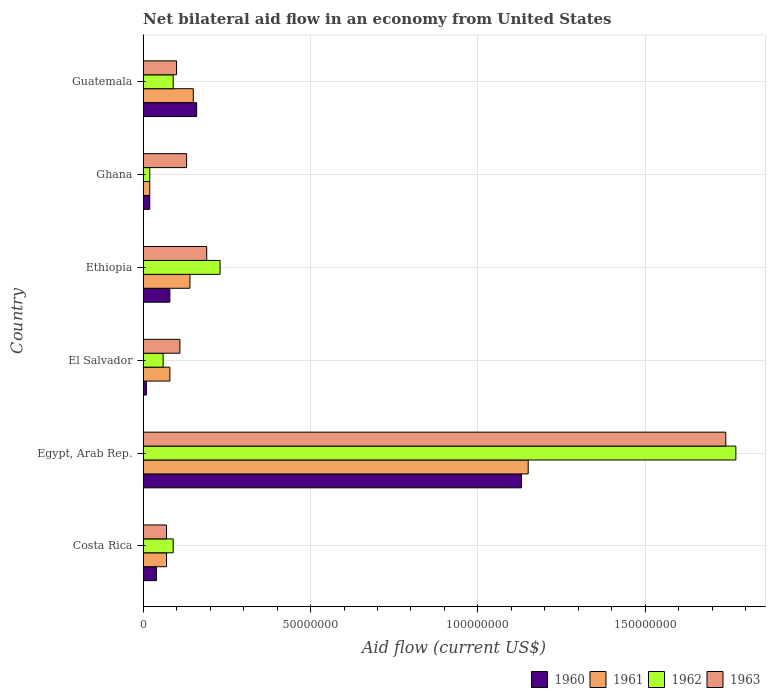How many groups of bars are there?
Offer a terse response. 6. Are the number of bars per tick equal to the number of legend labels?
Keep it short and to the point. Yes. How many bars are there on the 4th tick from the top?
Make the answer very short. 4. What is the label of the 1st group of bars from the top?
Your answer should be very brief. Guatemala. What is the net bilateral aid flow in 1960 in Costa Rica?
Your answer should be compact. 4.00e+06. Across all countries, what is the maximum net bilateral aid flow in 1960?
Keep it short and to the point. 1.13e+08. In which country was the net bilateral aid flow in 1962 maximum?
Give a very brief answer. Egypt, Arab Rep. In which country was the net bilateral aid flow in 1961 minimum?
Ensure brevity in your answer.  Ghana. What is the total net bilateral aid flow in 1961 in the graph?
Your answer should be very brief. 1.61e+08. What is the difference between the net bilateral aid flow in 1962 in Ghana and that in Guatemala?
Provide a short and direct response. -7.00e+06. What is the difference between the net bilateral aid flow in 1961 in Guatemala and the net bilateral aid flow in 1960 in Ethiopia?
Keep it short and to the point. 7.00e+06. What is the average net bilateral aid flow in 1961 per country?
Keep it short and to the point. 2.68e+07. What is the difference between the net bilateral aid flow in 1963 and net bilateral aid flow in 1962 in Ethiopia?
Provide a succinct answer. -4.00e+06. What is the ratio of the net bilateral aid flow in 1963 in Costa Rica to that in El Salvador?
Your response must be concise. 0.64. Is the difference between the net bilateral aid flow in 1963 in Egypt, Arab Rep. and Ghana greater than the difference between the net bilateral aid flow in 1962 in Egypt, Arab Rep. and Ghana?
Keep it short and to the point. No. What is the difference between the highest and the second highest net bilateral aid flow in 1961?
Your answer should be compact. 1.00e+08. What is the difference between the highest and the lowest net bilateral aid flow in 1963?
Provide a short and direct response. 1.67e+08. Is the sum of the net bilateral aid flow in 1961 in Ethiopia and Ghana greater than the maximum net bilateral aid flow in 1963 across all countries?
Provide a short and direct response. No. Is it the case that in every country, the sum of the net bilateral aid flow in 1960 and net bilateral aid flow in 1961 is greater than the sum of net bilateral aid flow in 1963 and net bilateral aid flow in 1962?
Your response must be concise. No. Is it the case that in every country, the sum of the net bilateral aid flow in 1963 and net bilateral aid flow in 1960 is greater than the net bilateral aid flow in 1961?
Provide a short and direct response. Yes. How many bars are there?
Provide a succinct answer. 24. How many countries are there in the graph?
Your response must be concise. 6. Are the values on the major ticks of X-axis written in scientific E-notation?
Offer a very short reply. No. Where does the legend appear in the graph?
Provide a short and direct response. Bottom right. How many legend labels are there?
Provide a succinct answer. 4. How are the legend labels stacked?
Offer a terse response. Horizontal. What is the title of the graph?
Provide a succinct answer. Net bilateral aid flow in an economy from United States. Does "2012" appear as one of the legend labels in the graph?
Provide a short and direct response. No. What is the Aid flow (current US$) in 1960 in Costa Rica?
Offer a terse response. 4.00e+06. What is the Aid flow (current US$) of 1962 in Costa Rica?
Keep it short and to the point. 9.00e+06. What is the Aid flow (current US$) of 1960 in Egypt, Arab Rep.?
Your response must be concise. 1.13e+08. What is the Aid flow (current US$) in 1961 in Egypt, Arab Rep.?
Offer a terse response. 1.15e+08. What is the Aid flow (current US$) in 1962 in Egypt, Arab Rep.?
Your answer should be compact. 1.77e+08. What is the Aid flow (current US$) of 1963 in Egypt, Arab Rep.?
Your response must be concise. 1.74e+08. What is the Aid flow (current US$) of 1960 in El Salvador?
Make the answer very short. 1.00e+06. What is the Aid flow (current US$) in 1961 in El Salvador?
Your response must be concise. 8.00e+06. What is the Aid flow (current US$) of 1963 in El Salvador?
Make the answer very short. 1.10e+07. What is the Aid flow (current US$) of 1961 in Ethiopia?
Ensure brevity in your answer.  1.40e+07. What is the Aid flow (current US$) of 1962 in Ethiopia?
Offer a very short reply. 2.30e+07. What is the Aid flow (current US$) of 1963 in Ethiopia?
Offer a terse response. 1.90e+07. What is the Aid flow (current US$) of 1963 in Ghana?
Make the answer very short. 1.30e+07. What is the Aid flow (current US$) of 1960 in Guatemala?
Offer a very short reply. 1.60e+07. What is the Aid flow (current US$) of 1961 in Guatemala?
Provide a succinct answer. 1.50e+07. What is the Aid flow (current US$) of 1962 in Guatemala?
Offer a terse response. 9.00e+06. What is the Aid flow (current US$) of 1963 in Guatemala?
Offer a terse response. 1.00e+07. Across all countries, what is the maximum Aid flow (current US$) of 1960?
Keep it short and to the point. 1.13e+08. Across all countries, what is the maximum Aid flow (current US$) of 1961?
Provide a succinct answer. 1.15e+08. Across all countries, what is the maximum Aid flow (current US$) of 1962?
Give a very brief answer. 1.77e+08. Across all countries, what is the maximum Aid flow (current US$) of 1963?
Provide a succinct answer. 1.74e+08. Across all countries, what is the minimum Aid flow (current US$) of 1960?
Your answer should be very brief. 1.00e+06. Across all countries, what is the minimum Aid flow (current US$) of 1962?
Provide a succinct answer. 2.00e+06. What is the total Aid flow (current US$) of 1960 in the graph?
Ensure brevity in your answer.  1.44e+08. What is the total Aid flow (current US$) in 1961 in the graph?
Your response must be concise. 1.61e+08. What is the total Aid flow (current US$) of 1962 in the graph?
Offer a very short reply. 2.26e+08. What is the total Aid flow (current US$) of 1963 in the graph?
Your answer should be compact. 2.34e+08. What is the difference between the Aid flow (current US$) of 1960 in Costa Rica and that in Egypt, Arab Rep.?
Provide a short and direct response. -1.09e+08. What is the difference between the Aid flow (current US$) of 1961 in Costa Rica and that in Egypt, Arab Rep.?
Your response must be concise. -1.08e+08. What is the difference between the Aid flow (current US$) of 1962 in Costa Rica and that in Egypt, Arab Rep.?
Provide a short and direct response. -1.68e+08. What is the difference between the Aid flow (current US$) in 1963 in Costa Rica and that in Egypt, Arab Rep.?
Provide a succinct answer. -1.67e+08. What is the difference between the Aid flow (current US$) in 1960 in Costa Rica and that in El Salvador?
Your answer should be very brief. 3.00e+06. What is the difference between the Aid flow (current US$) in 1961 in Costa Rica and that in El Salvador?
Give a very brief answer. -1.00e+06. What is the difference between the Aid flow (current US$) in 1963 in Costa Rica and that in El Salvador?
Keep it short and to the point. -4.00e+06. What is the difference between the Aid flow (current US$) of 1960 in Costa Rica and that in Ethiopia?
Make the answer very short. -4.00e+06. What is the difference between the Aid flow (current US$) of 1961 in Costa Rica and that in Ethiopia?
Ensure brevity in your answer.  -7.00e+06. What is the difference between the Aid flow (current US$) in 1962 in Costa Rica and that in Ethiopia?
Ensure brevity in your answer.  -1.40e+07. What is the difference between the Aid flow (current US$) in 1963 in Costa Rica and that in Ethiopia?
Offer a very short reply. -1.20e+07. What is the difference between the Aid flow (current US$) of 1962 in Costa Rica and that in Ghana?
Your answer should be very brief. 7.00e+06. What is the difference between the Aid flow (current US$) in 1963 in Costa Rica and that in Ghana?
Offer a very short reply. -6.00e+06. What is the difference between the Aid flow (current US$) of 1960 in Costa Rica and that in Guatemala?
Offer a very short reply. -1.20e+07. What is the difference between the Aid flow (current US$) of 1961 in Costa Rica and that in Guatemala?
Keep it short and to the point. -8.00e+06. What is the difference between the Aid flow (current US$) of 1960 in Egypt, Arab Rep. and that in El Salvador?
Keep it short and to the point. 1.12e+08. What is the difference between the Aid flow (current US$) in 1961 in Egypt, Arab Rep. and that in El Salvador?
Offer a very short reply. 1.07e+08. What is the difference between the Aid flow (current US$) of 1962 in Egypt, Arab Rep. and that in El Salvador?
Provide a succinct answer. 1.71e+08. What is the difference between the Aid flow (current US$) of 1963 in Egypt, Arab Rep. and that in El Salvador?
Offer a terse response. 1.63e+08. What is the difference between the Aid flow (current US$) in 1960 in Egypt, Arab Rep. and that in Ethiopia?
Ensure brevity in your answer.  1.05e+08. What is the difference between the Aid flow (current US$) of 1961 in Egypt, Arab Rep. and that in Ethiopia?
Your answer should be very brief. 1.01e+08. What is the difference between the Aid flow (current US$) in 1962 in Egypt, Arab Rep. and that in Ethiopia?
Offer a terse response. 1.54e+08. What is the difference between the Aid flow (current US$) in 1963 in Egypt, Arab Rep. and that in Ethiopia?
Your answer should be very brief. 1.55e+08. What is the difference between the Aid flow (current US$) in 1960 in Egypt, Arab Rep. and that in Ghana?
Make the answer very short. 1.11e+08. What is the difference between the Aid flow (current US$) in 1961 in Egypt, Arab Rep. and that in Ghana?
Your answer should be very brief. 1.13e+08. What is the difference between the Aid flow (current US$) in 1962 in Egypt, Arab Rep. and that in Ghana?
Offer a terse response. 1.75e+08. What is the difference between the Aid flow (current US$) in 1963 in Egypt, Arab Rep. and that in Ghana?
Offer a terse response. 1.61e+08. What is the difference between the Aid flow (current US$) in 1960 in Egypt, Arab Rep. and that in Guatemala?
Your answer should be very brief. 9.70e+07. What is the difference between the Aid flow (current US$) in 1962 in Egypt, Arab Rep. and that in Guatemala?
Offer a terse response. 1.68e+08. What is the difference between the Aid flow (current US$) of 1963 in Egypt, Arab Rep. and that in Guatemala?
Your answer should be very brief. 1.64e+08. What is the difference between the Aid flow (current US$) of 1960 in El Salvador and that in Ethiopia?
Provide a short and direct response. -7.00e+06. What is the difference between the Aid flow (current US$) in 1961 in El Salvador and that in Ethiopia?
Keep it short and to the point. -6.00e+06. What is the difference between the Aid flow (current US$) in 1962 in El Salvador and that in Ethiopia?
Make the answer very short. -1.70e+07. What is the difference between the Aid flow (current US$) of 1963 in El Salvador and that in Ethiopia?
Provide a succinct answer. -8.00e+06. What is the difference between the Aid flow (current US$) in 1960 in El Salvador and that in Ghana?
Your answer should be compact. -1.00e+06. What is the difference between the Aid flow (current US$) in 1961 in El Salvador and that in Ghana?
Ensure brevity in your answer.  6.00e+06. What is the difference between the Aid flow (current US$) of 1963 in El Salvador and that in Ghana?
Your answer should be very brief. -2.00e+06. What is the difference between the Aid flow (current US$) of 1960 in El Salvador and that in Guatemala?
Give a very brief answer. -1.50e+07. What is the difference between the Aid flow (current US$) in 1961 in El Salvador and that in Guatemala?
Provide a short and direct response. -7.00e+06. What is the difference between the Aid flow (current US$) in 1962 in El Salvador and that in Guatemala?
Your answer should be compact. -3.00e+06. What is the difference between the Aid flow (current US$) in 1963 in El Salvador and that in Guatemala?
Your answer should be very brief. 1.00e+06. What is the difference between the Aid flow (current US$) of 1961 in Ethiopia and that in Ghana?
Your response must be concise. 1.20e+07. What is the difference between the Aid flow (current US$) of 1962 in Ethiopia and that in Ghana?
Provide a short and direct response. 2.10e+07. What is the difference between the Aid flow (current US$) in 1960 in Ethiopia and that in Guatemala?
Your answer should be compact. -8.00e+06. What is the difference between the Aid flow (current US$) of 1962 in Ethiopia and that in Guatemala?
Your answer should be very brief. 1.40e+07. What is the difference between the Aid flow (current US$) of 1963 in Ethiopia and that in Guatemala?
Give a very brief answer. 9.00e+06. What is the difference between the Aid flow (current US$) in 1960 in Ghana and that in Guatemala?
Offer a very short reply. -1.40e+07. What is the difference between the Aid flow (current US$) of 1961 in Ghana and that in Guatemala?
Your answer should be very brief. -1.30e+07. What is the difference between the Aid flow (current US$) of 1962 in Ghana and that in Guatemala?
Your answer should be very brief. -7.00e+06. What is the difference between the Aid flow (current US$) of 1963 in Ghana and that in Guatemala?
Your answer should be very brief. 3.00e+06. What is the difference between the Aid flow (current US$) of 1960 in Costa Rica and the Aid flow (current US$) of 1961 in Egypt, Arab Rep.?
Your response must be concise. -1.11e+08. What is the difference between the Aid flow (current US$) of 1960 in Costa Rica and the Aid flow (current US$) of 1962 in Egypt, Arab Rep.?
Provide a short and direct response. -1.73e+08. What is the difference between the Aid flow (current US$) of 1960 in Costa Rica and the Aid flow (current US$) of 1963 in Egypt, Arab Rep.?
Make the answer very short. -1.70e+08. What is the difference between the Aid flow (current US$) of 1961 in Costa Rica and the Aid flow (current US$) of 1962 in Egypt, Arab Rep.?
Keep it short and to the point. -1.70e+08. What is the difference between the Aid flow (current US$) of 1961 in Costa Rica and the Aid flow (current US$) of 1963 in Egypt, Arab Rep.?
Ensure brevity in your answer.  -1.67e+08. What is the difference between the Aid flow (current US$) in 1962 in Costa Rica and the Aid flow (current US$) in 1963 in Egypt, Arab Rep.?
Give a very brief answer. -1.65e+08. What is the difference between the Aid flow (current US$) in 1960 in Costa Rica and the Aid flow (current US$) in 1961 in El Salvador?
Provide a succinct answer. -4.00e+06. What is the difference between the Aid flow (current US$) in 1960 in Costa Rica and the Aid flow (current US$) in 1963 in El Salvador?
Give a very brief answer. -7.00e+06. What is the difference between the Aid flow (current US$) of 1962 in Costa Rica and the Aid flow (current US$) of 1963 in El Salvador?
Your answer should be compact. -2.00e+06. What is the difference between the Aid flow (current US$) in 1960 in Costa Rica and the Aid flow (current US$) in 1961 in Ethiopia?
Offer a terse response. -1.00e+07. What is the difference between the Aid flow (current US$) of 1960 in Costa Rica and the Aid flow (current US$) of 1962 in Ethiopia?
Keep it short and to the point. -1.90e+07. What is the difference between the Aid flow (current US$) of 1960 in Costa Rica and the Aid flow (current US$) of 1963 in Ethiopia?
Give a very brief answer. -1.50e+07. What is the difference between the Aid flow (current US$) in 1961 in Costa Rica and the Aid flow (current US$) in 1962 in Ethiopia?
Give a very brief answer. -1.60e+07. What is the difference between the Aid flow (current US$) in 1961 in Costa Rica and the Aid flow (current US$) in 1963 in Ethiopia?
Your answer should be very brief. -1.20e+07. What is the difference between the Aid flow (current US$) in 1962 in Costa Rica and the Aid flow (current US$) in 1963 in Ethiopia?
Ensure brevity in your answer.  -1.00e+07. What is the difference between the Aid flow (current US$) in 1960 in Costa Rica and the Aid flow (current US$) in 1961 in Ghana?
Provide a succinct answer. 2.00e+06. What is the difference between the Aid flow (current US$) in 1960 in Costa Rica and the Aid flow (current US$) in 1963 in Ghana?
Provide a short and direct response. -9.00e+06. What is the difference between the Aid flow (current US$) of 1961 in Costa Rica and the Aid flow (current US$) of 1962 in Ghana?
Your answer should be very brief. 5.00e+06. What is the difference between the Aid flow (current US$) of 1961 in Costa Rica and the Aid flow (current US$) of 1963 in Ghana?
Keep it short and to the point. -6.00e+06. What is the difference between the Aid flow (current US$) of 1960 in Costa Rica and the Aid flow (current US$) of 1961 in Guatemala?
Provide a short and direct response. -1.10e+07. What is the difference between the Aid flow (current US$) in 1960 in Costa Rica and the Aid flow (current US$) in 1962 in Guatemala?
Your answer should be very brief. -5.00e+06. What is the difference between the Aid flow (current US$) of 1960 in Costa Rica and the Aid flow (current US$) of 1963 in Guatemala?
Offer a very short reply. -6.00e+06. What is the difference between the Aid flow (current US$) in 1961 in Costa Rica and the Aid flow (current US$) in 1963 in Guatemala?
Keep it short and to the point. -3.00e+06. What is the difference between the Aid flow (current US$) in 1962 in Costa Rica and the Aid flow (current US$) in 1963 in Guatemala?
Make the answer very short. -1.00e+06. What is the difference between the Aid flow (current US$) of 1960 in Egypt, Arab Rep. and the Aid flow (current US$) of 1961 in El Salvador?
Keep it short and to the point. 1.05e+08. What is the difference between the Aid flow (current US$) of 1960 in Egypt, Arab Rep. and the Aid flow (current US$) of 1962 in El Salvador?
Provide a succinct answer. 1.07e+08. What is the difference between the Aid flow (current US$) of 1960 in Egypt, Arab Rep. and the Aid flow (current US$) of 1963 in El Salvador?
Make the answer very short. 1.02e+08. What is the difference between the Aid flow (current US$) in 1961 in Egypt, Arab Rep. and the Aid flow (current US$) in 1962 in El Salvador?
Keep it short and to the point. 1.09e+08. What is the difference between the Aid flow (current US$) of 1961 in Egypt, Arab Rep. and the Aid flow (current US$) of 1963 in El Salvador?
Your answer should be very brief. 1.04e+08. What is the difference between the Aid flow (current US$) of 1962 in Egypt, Arab Rep. and the Aid flow (current US$) of 1963 in El Salvador?
Offer a terse response. 1.66e+08. What is the difference between the Aid flow (current US$) of 1960 in Egypt, Arab Rep. and the Aid flow (current US$) of 1961 in Ethiopia?
Provide a succinct answer. 9.90e+07. What is the difference between the Aid flow (current US$) in 1960 in Egypt, Arab Rep. and the Aid flow (current US$) in 1962 in Ethiopia?
Your response must be concise. 9.00e+07. What is the difference between the Aid flow (current US$) in 1960 in Egypt, Arab Rep. and the Aid flow (current US$) in 1963 in Ethiopia?
Your response must be concise. 9.40e+07. What is the difference between the Aid flow (current US$) of 1961 in Egypt, Arab Rep. and the Aid flow (current US$) of 1962 in Ethiopia?
Offer a very short reply. 9.20e+07. What is the difference between the Aid flow (current US$) of 1961 in Egypt, Arab Rep. and the Aid flow (current US$) of 1963 in Ethiopia?
Provide a succinct answer. 9.60e+07. What is the difference between the Aid flow (current US$) of 1962 in Egypt, Arab Rep. and the Aid flow (current US$) of 1963 in Ethiopia?
Your answer should be compact. 1.58e+08. What is the difference between the Aid flow (current US$) in 1960 in Egypt, Arab Rep. and the Aid flow (current US$) in 1961 in Ghana?
Keep it short and to the point. 1.11e+08. What is the difference between the Aid flow (current US$) of 1960 in Egypt, Arab Rep. and the Aid flow (current US$) of 1962 in Ghana?
Give a very brief answer. 1.11e+08. What is the difference between the Aid flow (current US$) of 1960 in Egypt, Arab Rep. and the Aid flow (current US$) of 1963 in Ghana?
Provide a short and direct response. 1.00e+08. What is the difference between the Aid flow (current US$) in 1961 in Egypt, Arab Rep. and the Aid flow (current US$) in 1962 in Ghana?
Your answer should be compact. 1.13e+08. What is the difference between the Aid flow (current US$) of 1961 in Egypt, Arab Rep. and the Aid flow (current US$) of 1963 in Ghana?
Give a very brief answer. 1.02e+08. What is the difference between the Aid flow (current US$) of 1962 in Egypt, Arab Rep. and the Aid flow (current US$) of 1963 in Ghana?
Your answer should be very brief. 1.64e+08. What is the difference between the Aid flow (current US$) of 1960 in Egypt, Arab Rep. and the Aid flow (current US$) of 1961 in Guatemala?
Offer a very short reply. 9.80e+07. What is the difference between the Aid flow (current US$) in 1960 in Egypt, Arab Rep. and the Aid flow (current US$) in 1962 in Guatemala?
Provide a succinct answer. 1.04e+08. What is the difference between the Aid flow (current US$) in 1960 in Egypt, Arab Rep. and the Aid flow (current US$) in 1963 in Guatemala?
Your answer should be compact. 1.03e+08. What is the difference between the Aid flow (current US$) in 1961 in Egypt, Arab Rep. and the Aid flow (current US$) in 1962 in Guatemala?
Ensure brevity in your answer.  1.06e+08. What is the difference between the Aid flow (current US$) of 1961 in Egypt, Arab Rep. and the Aid flow (current US$) of 1963 in Guatemala?
Keep it short and to the point. 1.05e+08. What is the difference between the Aid flow (current US$) of 1962 in Egypt, Arab Rep. and the Aid flow (current US$) of 1963 in Guatemala?
Your answer should be very brief. 1.67e+08. What is the difference between the Aid flow (current US$) of 1960 in El Salvador and the Aid flow (current US$) of 1961 in Ethiopia?
Make the answer very short. -1.30e+07. What is the difference between the Aid flow (current US$) in 1960 in El Salvador and the Aid flow (current US$) in 1962 in Ethiopia?
Provide a short and direct response. -2.20e+07. What is the difference between the Aid flow (current US$) in 1960 in El Salvador and the Aid flow (current US$) in 1963 in Ethiopia?
Your response must be concise. -1.80e+07. What is the difference between the Aid flow (current US$) in 1961 in El Salvador and the Aid flow (current US$) in 1962 in Ethiopia?
Ensure brevity in your answer.  -1.50e+07. What is the difference between the Aid flow (current US$) in 1961 in El Salvador and the Aid flow (current US$) in 1963 in Ethiopia?
Ensure brevity in your answer.  -1.10e+07. What is the difference between the Aid flow (current US$) in 1962 in El Salvador and the Aid flow (current US$) in 1963 in Ethiopia?
Your answer should be very brief. -1.30e+07. What is the difference between the Aid flow (current US$) in 1960 in El Salvador and the Aid flow (current US$) in 1962 in Ghana?
Offer a very short reply. -1.00e+06. What is the difference between the Aid flow (current US$) in 1960 in El Salvador and the Aid flow (current US$) in 1963 in Ghana?
Your answer should be very brief. -1.20e+07. What is the difference between the Aid flow (current US$) of 1961 in El Salvador and the Aid flow (current US$) of 1962 in Ghana?
Provide a succinct answer. 6.00e+06. What is the difference between the Aid flow (current US$) in 1961 in El Salvador and the Aid flow (current US$) in 1963 in Ghana?
Keep it short and to the point. -5.00e+06. What is the difference between the Aid flow (current US$) in 1962 in El Salvador and the Aid flow (current US$) in 1963 in Ghana?
Make the answer very short. -7.00e+06. What is the difference between the Aid flow (current US$) of 1960 in El Salvador and the Aid flow (current US$) of 1961 in Guatemala?
Keep it short and to the point. -1.40e+07. What is the difference between the Aid flow (current US$) of 1960 in El Salvador and the Aid flow (current US$) of 1962 in Guatemala?
Your answer should be compact. -8.00e+06. What is the difference between the Aid flow (current US$) of 1960 in El Salvador and the Aid flow (current US$) of 1963 in Guatemala?
Keep it short and to the point. -9.00e+06. What is the difference between the Aid flow (current US$) in 1961 in El Salvador and the Aid flow (current US$) in 1962 in Guatemala?
Offer a very short reply. -1.00e+06. What is the difference between the Aid flow (current US$) in 1962 in El Salvador and the Aid flow (current US$) in 1963 in Guatemala?
Your answer should be compact. -4.00e+06. What is the difference between the Aid flow (current US$) of 1960 in Ethiopia and the Aid flow (current US$) of 1961 in Ghana?
Offer a terse response. 6.00e+06. What is the difference between the Aid flow (current US$) of 1960 in Ethiopia and the Aid flow (current US$) of 1963 in Ghana?
Offer a very short reply. -5.00e+06. What is the difference between the Aid flow (current US$) of 1961 in Ethiopia and the Aid flow (current US$) of 1962 in Ghana?
Keep it short and to the point. 1.20e+07. What is the difference between the Aid flow (current US$) in 1962 in Ethiopia and the Aid flow (current US$) in 1963 in Ghana?
Make the answer very short. 1.00e+07. What is the difference between the Aid flow (current US$) in 1960 in Ethiopia and the Aid flow (current US$) in 1961 in Guatemala?
Keep it short and to the point. -7.00e+06. What is the difference between the Aid flow (current US$) in 1960 in Ethiopia and the Aid flow (current US$) in 1962 in Guatemala?
Ensure brevity in your answer.  -1.00e+06. What is the difference between the Aid flow (current US$) of 1960 in Ethiopia and the Aid flow (current US$) of 1963 in Guatemala?
Keep it short and to the point. -2.00e+06. What is the difference between the Aid flow (current US$) of 1961 in Ethiopia and the Aid flow (current US$) of 1962 in Guatemala?
Keep it short and to the point. 5.00e+06. What is the difference between the Aid flow (current US$) in 1961 in Ethiopia and the Aid flow (current US$) in 1963 in Guatemala?
Ensure brevity in your answer.  4.00e+06. What is the difference between the Aid flow (current US$) of 1962 in Ethiopia and the Aid flow (current US$) of 1963 in Guatemala?
Give a very brief answer. 1.30e+07. What is the difference between the Aid flow (current US$) of 1960 in Ghana and the Aid flow (current US$) of 1961 in Guatemala?
Give a very brief answer. -1.30e+07. What is the difference between the Aid flow (current US$) of 1960 in Ghana and the Aid flow (current US$) of 1962 in Guatemala?
Your answer should be compact. -7.00e+06. What is the difference between the Aid flow (current US$) of 1960 in Ghana and the Aid flow (current US$) of 1963 in Guatemala?
Your response must be concise. -8.00e+06. What is the difference between the Aid flow (current US$) of 1961 in Ghana and the Aid flow (current US$) of 1962 in Guatemala?
Your response must be concise. -7.00e+06. What is the difference between the Aid flow (current US$) of 1961 in Ghana and the Aid flow (current US$) of 1963 in Guatemala?
Provide a short and direct response. -8.00e+06. What is the difference between the Aid flow (current US$) in 1962 in Ghana and the Aid flow (current US$) in 1963 in Guatemala?
Offer a terse response. -8.00e+06. What is the average Aid flow (current US$) in 1960 per country?
Offer a terse response. 2.40e+07. What is the average Aid flow (current US$) in 1961 per country?
Provide a succinct answer. 2.68e+07. What is the average Aid flow (current US$) of 1962 per country?
Make the answer very short. 3.77e+07. What is the average Aid flow (current US$) of 1963 per country?
Provide a succinct answer. 3.90e+07. What is the difference between the Aid flow (current US$) in 1960 and Aid flow (current US$) in 1962 in Costa Rica?
Give a very brief answer. -5.00e+06. What is the difference between the Aid flow (current US$) of 1960 and Aid flow (current US$) of 1963 in Costa Rica?
Your answer should be compact. -3.00e+06. What is the difference between the Aid flow (current US$) in 1961 and Aid flow (current US$) in 1962 in Costa Rica?
Keep it short and to the point. -2.00e+06. What is the difference between the Aid flow (current US$) in 1961 and Aid flow (current US$) in 1963 in Costa Rica?
Offer a terse response. 0. What is the difference between the Aid flow (current US$) of 1962 and Aid flow (current US$) of 1963 in Costa Rica?
Ensure brevity in your answer.  2.00e+06. What is the difference between the Aid flow (current US$) of 1960 and Aid flow (current US$) of 1961 in Egypt, Arab Rep.?
Give a very brief answer. -2.00e+06. What is the difference between the Aid flow (current US$) of 1960 and Aid flow (current US$) of 1962 in Egypt, Arab Rep.?
Ensure brevity in your answer.  -6.40e+07. What is the difference between the Aid flow (current US$) of 1960 and Aid flow (current US$) of 1963 in Egypt, Arab Rep.?
Offer a very short reply. -6.10e+07. What is the difference between the Aid flow (current US$) of 1961 and Aid flow (current US$) of 1962 in Egypt, Arab Rep.?
Provide a succinct answer. -6.20e+07. What is the difference between the Aid flow (current US$) of 1961 and Aid flow (current US$) of 1963 in Egypt, Arab Rep.?
Give a very brief answer. -5.90e+07. What is the difference between the Aid flow (current US$) of 1960 and Aid flow (current US$) of 1961 in El Salvador?
Offer a very short reply. -7.00e+06. What is the difference between the Aid flow (current US$) in 1960 and Aid flow (current US$) in 1962 in El Salvador?
Keep it short and to the point. -5.00e+06. What is the difference between the Aid flow (current US$) in 1960 and Aid flow (current US$) in 1963 in El Salvador?
Offer a terse response. -1.00e+07. What is the difference between the Aid flow (current US$) in 1961 and Aid flow (current US$) in 1962 in El Salvador?
Offer a terse response. 2.00e+06. What is the difference between the Aid flow (current US$) in 1961 and Aid flow (current US$) in 1963 in El Salvador?
Make the answer very short. -3.00e+06. What is the difference between the Aid flow (current US$) of 1962 and Aid flow (current US$) of 1963 in El Salvador?
Provide a succinct answer. -5.00e+06. What is the difference between the Aid flow (current US$) of 1960 and Aid flow (current US$) of 1961 in Ethiopia?
Your answer should be very brief. -6.00e+06. What is the difference between the Aid flow (current US$) of 1960 and Aid flow (current US$) of 1962 in Ethiopia?
Provide a succinct answer. -1.50e+07. What is the difference between the Aid flow (current US$) in 1960 and Aid flow (current US$) in 1963 in Ethiopia?
Your answer should be compact. -1.10e+07. What is the difference between the Aid flow (current US$) in 1961 and Aid flow (current US$) in 1962 in Ethiopia?
Ensure brevity in your answer.  -9.00e+06. What is the difference between the Aid flow (current US$) in 1961 and Aid flow (current US$) in 1963 in Ethiopia?
Your response must be concise. -5.00e+06. What is the difference between the Aid flow (current US$) in 1962 and Aid flow (current US$) in 1963 in Ethiopia?
Your response must be concise. 4.00e+06. What is the difference between the Aid flow (current US$) of 1960 and Aid flow (current US$) of 1961 in Ghana?
Offer a terse response. 0. What is the difference between the Aid flow (current US$) in 1960 and Aid flow (current US$) in 1963 in Ghana?
Provide a succinct answer. -1.10e+07. What is the difference between the Aid flow (current US$) in 1961 and Aid flow (current US$) in 1963 in Ghana?
Make the answer very short. -1.10e+07. What is the difference between the Aid flow (current US$) of 1962 and Aid flow (current US$) of 1963 in Ghana?
Ensure brevity in your answer.  -1.10e+07. What is the difference between the Aid flow (current US$) of 1960 and Aid flow (current US$) of 1963 in Guatemala?
Provide a short and direct response. 6.00e+06. What is the ratio of the Aid flow (current US$) of 1960 in Costa Rica to that in Egypt, Arab Rep.?
Provide a succinct answer. 0.04. What is the ratio of the Aid flow (current US$) in 1961 in Costa Rica to that in Egypt, Arab Rep.?
Offer a terse response. 0.06. What is the ratio of the Aid flow (current US$) in 1962 in Costa Rica to that in Egypt, Arab Rep.?
Ensure brevity in your answer.  0.05. What is the ratio of the Aid flow (current US$) in 1963 in Costa Rica to that in Egypt, Arab Rep.?
Offer a terse response. 0.04. What is the ratio of the Aid flow (current US$) in 1961 in Costa Rica to that in El Salvador?
Provide a short and direct response. 0.88. What is the ratio of the Aid flow (current US$) of 1963 in Costa Rica to that in El Salvador?
Give a very brief answer. 0.64. What is the ratio of the Aid flow (current US$) of 1960 in Costa Rica to that in Ethiopia?
Provide a succinct answer. 0.5. What is the ratio of the Aid flow (current US$) in 1962 in Costa Rica to that in Ethiopia?
Make the answer very short. 0.39. What is the ratio of the Aid flow (current US$) in 1963 in Costa Rica to that in Ethiopia?
Your answer should be compact. 0.37. What is the ratio of the Aid flow (current US$) in 1960 in Costa Rica to that in Ghana?
Make the answer very short. 2. What is the ratio of the Aid flow (current US$) in 1962 in Costa Rica to that in Ghana?
Ensure brevity in your answer.  4.5. What is the ratio of the Aid flow (current US$) of 1963 in Costa Rica to that in Ghana?
Your answer should be compact. 0.54. What is the ratio of the Aid flow (current US$) of 1960 in Costa Rica to that in Guatemala?
Offer a very short reply. 0.25. What is the ratio of the Aid flow (current US$) of 1961 in Costa Rica to that in Guatemala?
Keep it short and to the point. 0.47. What is the ratio of the Aid flow (current US$) of 1963 in Costa Rica to that in Guatemala?
Your response must be concise. 0.7. What is the ratio of the Aid flow (current US$) of 1960 in Egypt, Arab Rep. to that in El Salvador?
Give a very brief answer. 113. What is the ratio of the Aid flow (current US$) of 1961 in Egypt, Arab Rep. to that in El Salvador?
Ensure brevity in your answer.  14.38. What is the ratio of the Aid flow (current US$) of 1962 in Egypt, Arab Rep. to that in El Salvador?
Provide a succinct answer. 29.5. What is the ratio of the Aid flow (current US$) of 1963 in Egypt, Arab Rep. to that in El Salvador?
Provide a succinct answer. 15.82. What is the ratio of the Aid flow (current US$) in 1960 in Egypt, Arab Rep. to that in Ethiopia?
Provide a short and direct response. 14.12. What is the ratio of the Aid flow (current US$) of 1961 in Egypt, Arab Rep. to that in Ethiopia?
Your answer should be very brief. 8.21. What is the ratio of the Aid flow (current US$) in 1962 in Egypt, Arab Rep. to that in Ethiopia?
Ensure brevity in your answer.  7.7. What is the ratio of the Aid flow (current US$) in 1963 in Egypt, Arab Rep. to that in Ethiopia?
Your answer should be very brief. 9.16. What is the ratio of the Aid flow (current US$) in 1960 in Egypt, Arab Rep. to that in Ghana?
Give a very brief answer. 56.5. What is the ratio of the Aid flow (current US$) of 1961 in Egypt, Arab Rep. to that in Ghana?
Your response must be concise. 57.5. What is the ratio of the Aid flow (current US$) in 1962 in Egypt, Arab Rep. to that in Ghana?
Give a very brief answer. 88.5. What is the ratio of the Aid flow (current US$) of 1963 in Egypt, Arab Rep. to that in Ghana?
Your response must be concise. 13.38. What is the ratio of the Aid flow (current US$) in 1960 in Egypt, Arab Rep. to that in Guatemala?
Provide a succinct answer. 7.06. What is the ratio of the Aid flow (current US$) of 1961 in Egypt, Arab Rep. to that in Guatemala?
Keep it short and to the point. 7.67. What is the ratio of the Aid flow (current US$) in 1962 in Egypt, Arab Rep. to that in Guatemala?
Provide a short and direct response. 19.67. What is the ratio of the Aid flow (current US$) in 1961 in El Salvador to that in Ethiopia?
Provide a succinct answer. 0.57. What is the ratio of the Aid flow (current US$) in 1962 in El Salvador to that in Ethiopia?
Your response must be concise. 0.26. What is the ratio of the Aid flow (current US$) in 1963 in El Salvador to that in Ethiopia?
Your response must be concise. 0.58. What is the ratio of the Aid flow (current US$) of 1960 in El Salvador to that in Ghana?
Keep it short and to the point. 0.5. What is the ratio of the Aid flow (current US$) of 1962 in El Salvador to that in Ghana?
Give a very brief answer. 3. What is the ratio of the Aid flow (current US$) in 1963 in El Salvador to that in Ghana?
Keep it short and to the point. 0.85. What is the ratio of the Aid flow (current US$) of 1960 in El Salvador to that in Guatemala?
Offer a very short reply. 0.06. What is the ratio of the Aid flow (current US$) of 1961 in El Salvador to that in Guatemala?
Provide a short and direct response. 0.53. What is the ratio of the Aid flow (current US$) of 1962 in El Salvador to that in Guatemala?
Keep it short and to the point. 0.67. What is the ratio of the Aid flow (current US$) in 1960 in Ethiopia to that in Ghana?
Your response must be concise. 4. What is the ratio of the Aid flow (current US$) of 1963 in Ethiopia to that in Ghana?
Your response must be concise. 1.46. What is the ratio of the Aid flow (current US$) of 1962 in Ethiopia to that in Guatemala?
Your answer should be compact. 2.56. What is the ratio of the Aid flow (current US$) in 1963 in Ethiopia to that in Guatemala?
Keep it short and to the point. 1.9. What is the ratio of the Aid flow (current US$) in 1961 in Ghana to that in Guatemala?
Make the answer very short. 0.13. What is the ratio of the Aid flow (current US$) in 1962 in Ghana to that in Guatemala?
Make the answer very short. 0.22. What is the ratio of the Aid flow (current US$) in 1963 in Ghana to that in Guatemala?
Ensure brevity in your answer.  1.3. What is the difference between the highest and the second highest Aid flow (current US$) in 1960?
Ensure brevity in your answer.  9.70e+07. What is the difference between the highest and the second highest Aid flow (current US$) in 1961?
Ensure brevity in your answer.  1.00e+08. What is the difference between the highest and the second highest Aid flow (current US$) of 1962?
Offer a terse response. 1.54e+08. What is the difference between the highest and the second highest Aid flow (current US$) of 1963?
Your answer should be very brief. 1.55e+08. What is the difference between the highest and the lowest Aid flow (current US$) of 1960?
Offer a very short reply. 1.12e+08. What is the difference between the highest and the lowest Aid flow (current US$) of 1961?
Keep it short and to the point. 1.13e+08. What is the difference between the highest and the lowest Aid flow (current US$) in 1962?
Offer a very short reply. 1.75e+08. What is the difference between the highest and the lowest Aid flow (current US$) of 1963?
Offer a terse response. 1.67e+08. 